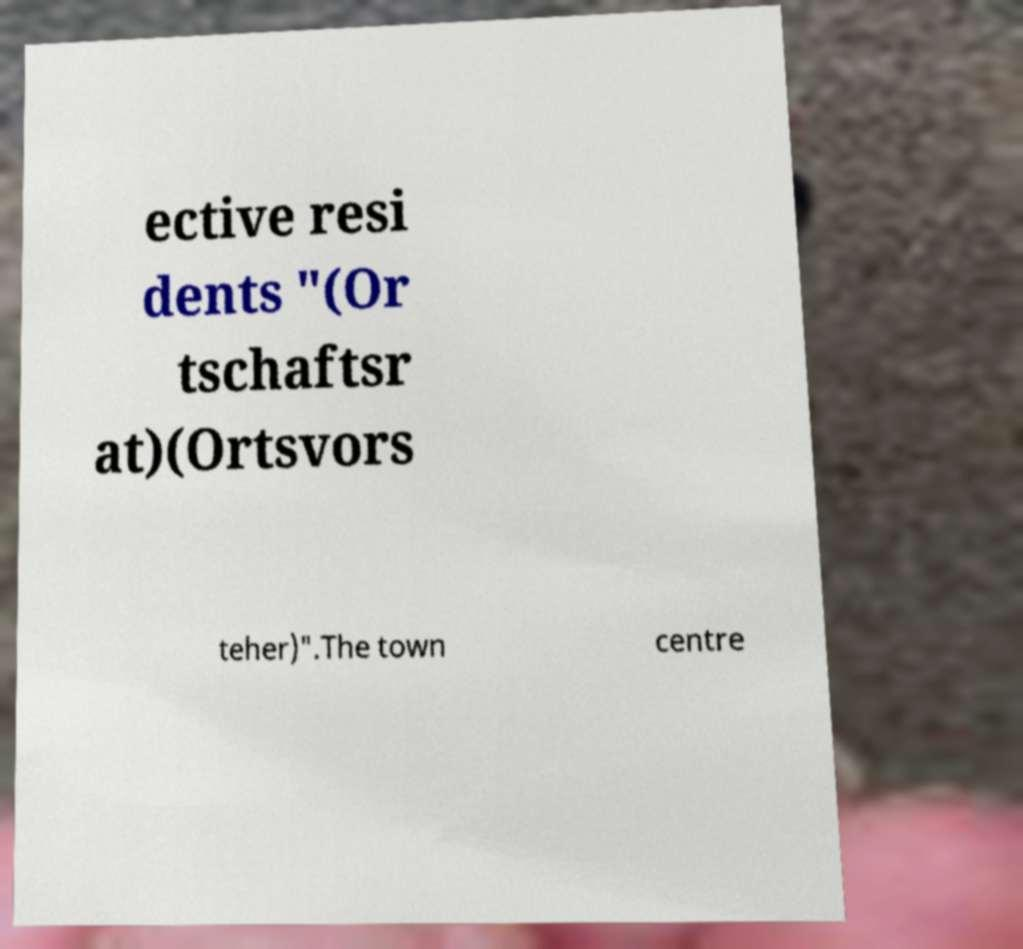Please read and relay the text visible in this image. What does it say? ective resi dents "(Or tschaftsr at)(Ortsvors teher)".The town centre 